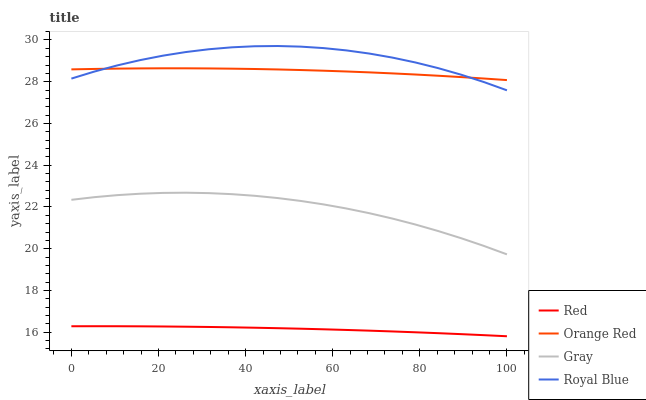Does Red have the minimum area under the curve?
Answer yes or no. Yes. Does Royal Blue have the maximum area under the curve?
Answer yes or no. Yes. Does Orange Red have the minimum area under the curve?
Answer yes or no. No. Does Orange Red have the maximum area under the curve?
Answer yes or no. No. Is Red the smoothest?
Answer yes or no. Yes. Is Royal Blue the roughest?
Answer yes or no. Yes. Is Orange Red the smoothest?
Answer yes or no. No. Is Orange Red the roughest?
Answer yes or no. No. Does Red have the lowest value?
Answer yes or no. Yes. Does Orange Red have the lowest value?
Answer yes or no. No. Does Royal Blue have the highest value?
Answer yes or no. Yes. Does Orange Red have the highest value?
Answer yes or no. No. Is Gray less than Royal Blue?
Answer yes or no. Yes. Is Royal Blue greater than Gray?
Answer yes or no. Yes. Does Royal Blue intersect Orange Red?
Answer yes or no. Yes. Is Royal Blue less than Orange Red?
Answer yes or no. No. Is Royal Blue greater than Orange Red?
Answer yes or no. No. Does Gray intersect Royal Blue?
Answer yes or no. No. 